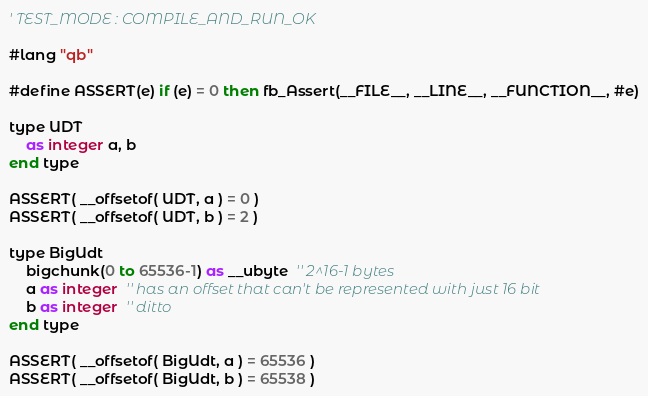Convert code to text. <code><loc_0><loc_0><loc_500><loc_500><_VisualBasic_>' TEST_MODE : COMPILE_AND_RUN_OK

#lang "qb"

#define ASSERT(e) if (e) = 0 then fb_Assert(__FILE__, __LINE__, __FUNCTION__, #e)

type UDT
	as integer a, b
end type

ASSERT( __offsetof( UDT, a ) = 0 )
ASSERT( __offsetof( UDT, b ) = 2 )

type BigUdt
	bigchunk(0 to 65536-1) as __ubyte  '' 2^16-1 bytes
	a as integer  '' has an offset that can't be represented with just 16 bit
	b as integer  '' ditto
end type

ASSERT( __offsetof( BigUdt, a ) = 65536 )
ASSERT( __offsetof( BigUdt, b ) = 65538 )
</code> 